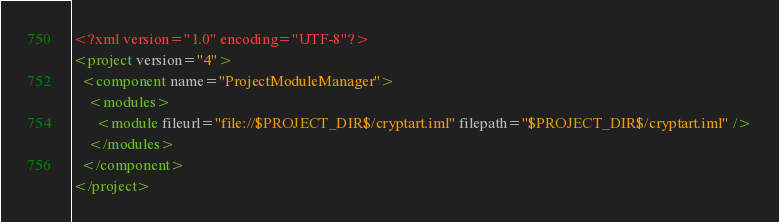Convert code to text. <code><loc_0><loc_0><loc_500><loc_500><_XML_><?xml version="1.0" encoding="UTF-8"?>
<project version="4">
  <component name="ProjectModuleManager">
    <modules>
      <module fileurl="file://$PROJECT_DIR$/cryptart.iml" filepath="$PROJECT_DIR$/cryptart.iml" />
    </modules>
  </component>
</project></code> 